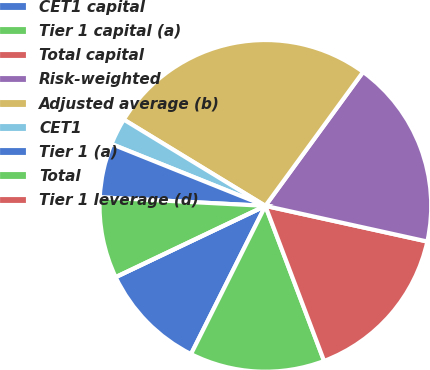<chart> <loc_0><loc_0><loc_500><loc_500><pie_chart><fcel>CET1 capital<fcel>Tier 1 capital (a)<fcel>Total capital<fcel>Risk-weighted<fcel>Adjusted average (b)<fcel>CET1<fcel>Tier 1 (a)<fcel>Total<fcel>Tier 1 leverage (d)<nl><fcel>10.53%<fcel>13.16%<fcel>15.79%<fcel>18.42%<fcel>26.32%<fcel>2.63%<fcel>5.26%<fcel>7.89%<fcel>0.0%<nl></chart> 